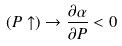<formula> <loc_0><loc_0><loc_500><loc_500>( P \uparrow ) \rightarrow \frac { \partial \alpha } { \partial P } < 0</formula> 